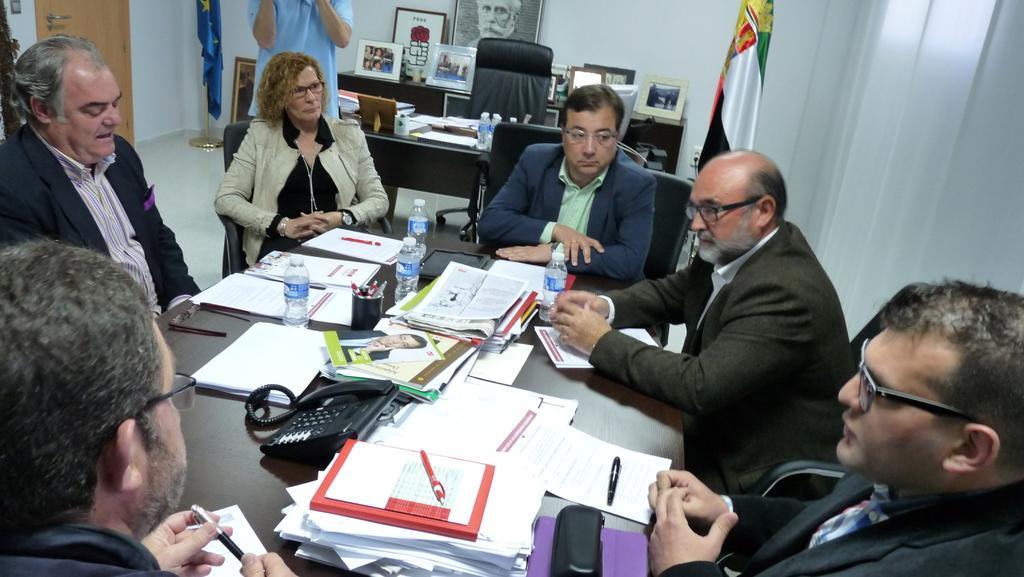Please provide a concise description of this image. There are few persons sitting on the chairs. This is a table. On the table there are books, papers, phone, spectacles, holder, pens, box, and bottles. There is a person standing on the floor. Here we can see flags, tables, chair, and frames. There is a door. In the background we can see wall. 